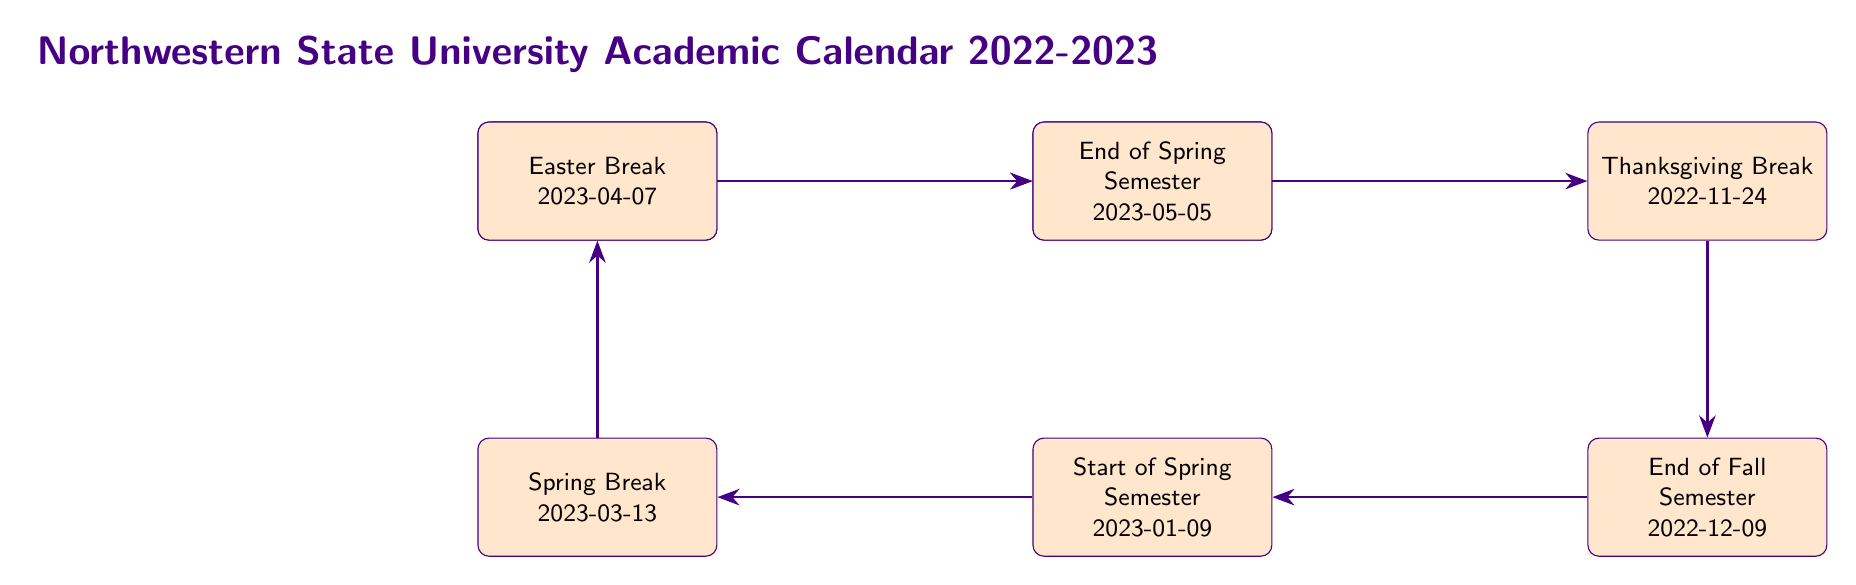What day does the Fall Semester start? The diagram indicates the start date of the Fall Semester in the first node. It explicitly states "Start of Fall Semester" followed by the date "2022-08-15."
Answer: 2022-08-15 How many breaks are listed in the academic calendar? To find the number of breaks, we count the relevant events in the diagram, which includes Fall Break, Thanksgiving Break, Spring Break, and Easter Break, totaling four breaks.
Answer: 4 What is the date of the End of Fall Semester? The diagram clearly states "End of Fall Semester" followed by "2022-12-09," placing this information in the corresponding node.
Answer: 2022-12-09 What event occurs immediately after the Thanksgiving Break? By following the arrows in the diagram, we see that the event directly after the Thanksgiving Break node is the End of Fall Semester.
Answer: End of Fall Semester Which semester starts on January 9, 2023? The diagram identifies the event "Start of Spring Semester" and associates it with the specific date "2023-01-09." This is the semester being asked about.
Answer: Spring Semester What is the sequence of breaks between the Fall Semester and the End of Spring Semester? To answer this, I follow the arrows to trace the sequence: Fall Break, Thanksgiving Break, then End of Fall Semester, Start of Spring Semester, followed by Spring Break, Easter Break, and finally the End of Spring Semester.
Answer: Fall Break, Thanksgiving Break, Spring Break, Easter Break How is the End of Spring Semester related to the Start of Spring Semester? The diagram shows an arrow pointing from the Start of Spring Semester to the End of Spring Semester, illustrating that the End occurs after the Start.
Answer: Sequential relationship What color is used to fill the event nodes? The diagram specifies the fill color for event nodes as "nsuOrange!20," indicating a bright orange shade for visibility.
Answer: nsuOrange!20 What is the title of the academic calendar diagram? By examining the top of the diagram, we find the large text stating "Northwestern State University Academic Calendar 2022-2023." This represents the title of the entire diagram.
Answer: Northwestern State University Academic Calendar 2022-2023 